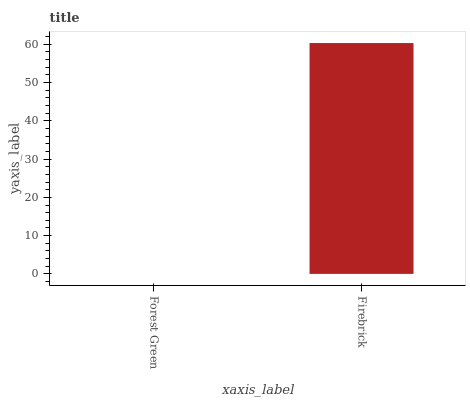Is Forest Green the minimum?
Answer yes or no. Yes. Is Firebrick the maximum?
Answer yes or no. Yes. Is Firebrick the minimum?
Answer yes or no. No. Is Firebrick greater than Forest Green?
Answer yes or no. Yes. Is Forest Green less than Firebrick?
Answer yes or no. Yes. Is Forest Green greater than Firebrick?
Answer yes or no. No. Is Firebrick less than Forest Green?
Answer yes or no. No. Is Firebrick the high median?
Answer yes or no. Yes. Is Forest Green the low median?
Answer yes or no. Yes. Is Forest Green the high median?
Answer yes or no. No. Is Firebrick the low median?
Answer yes or no. No. 